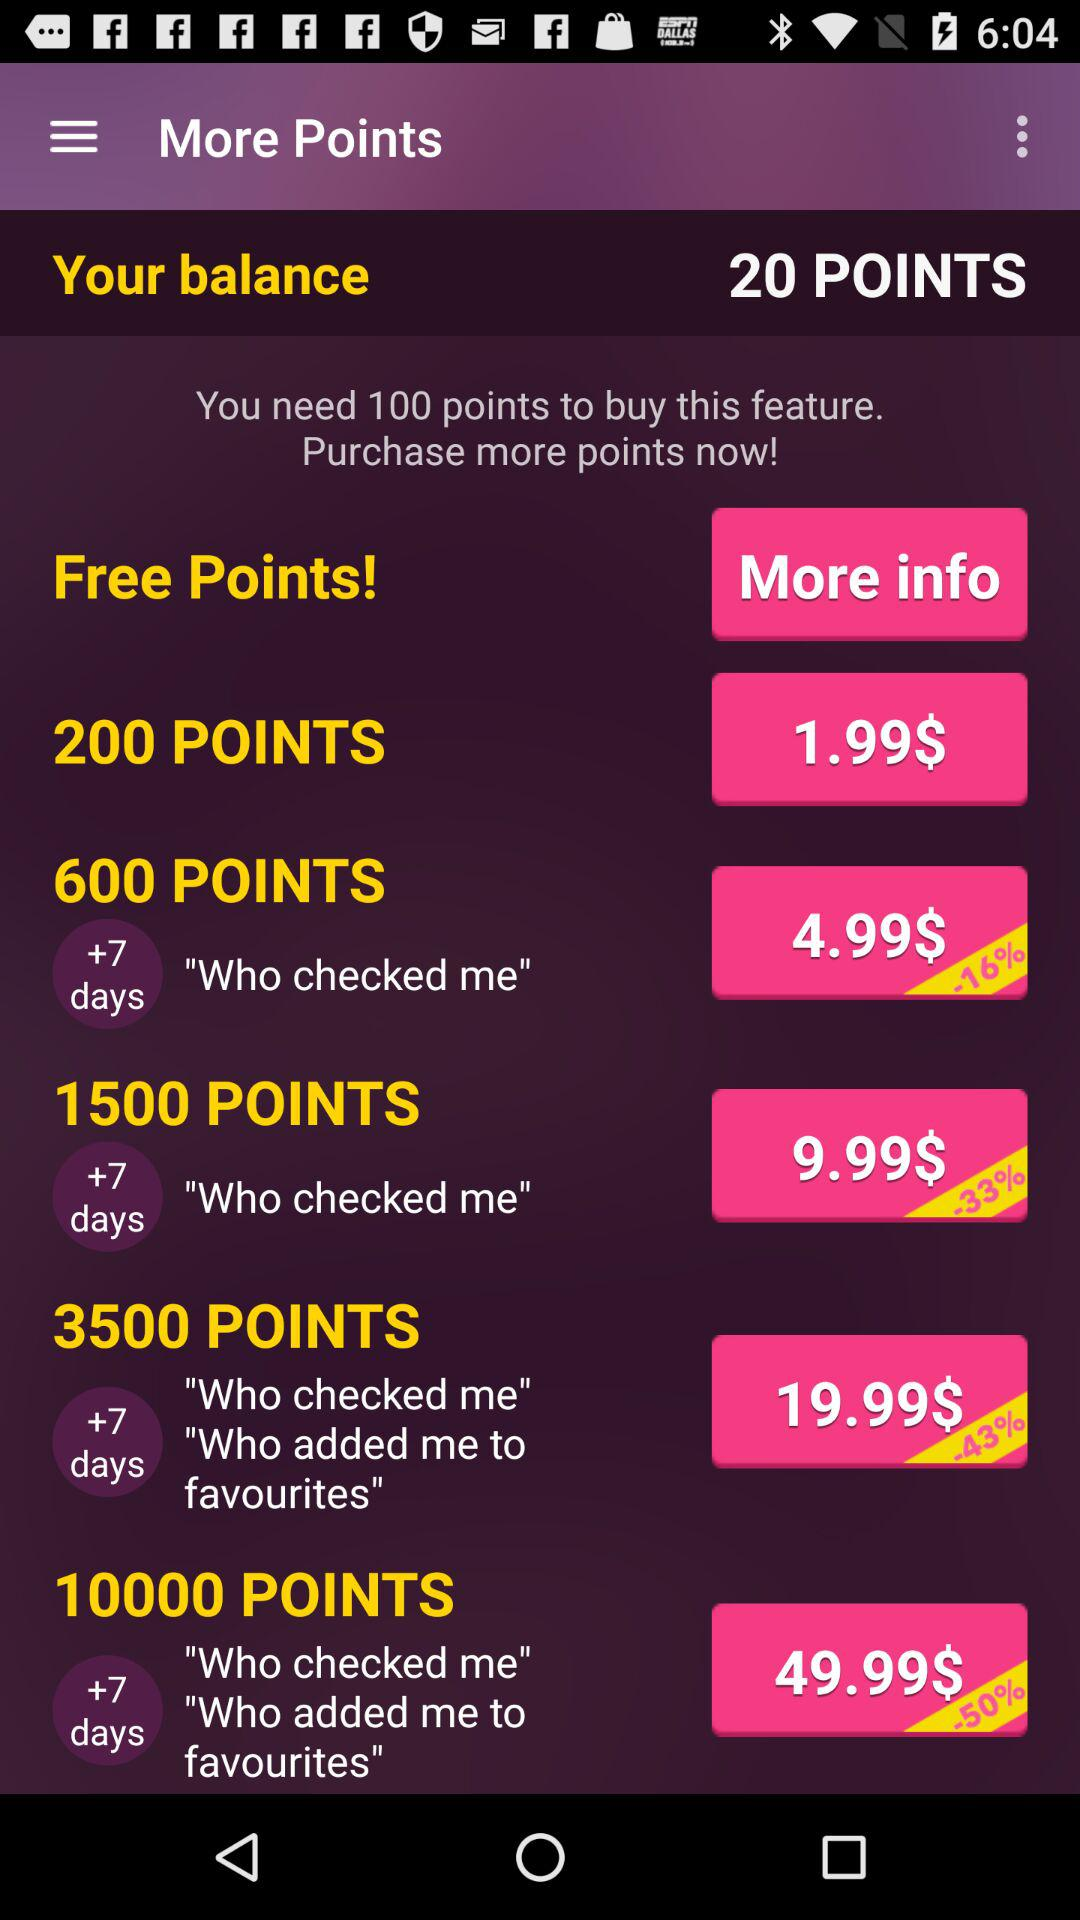What is the percentage off on buying 10,000 points? There is a 50% off on buying 10,000 points. 